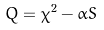Convert formula to latex. <formula><loc_0><loc_0><loc_500><loc_500>Q = \chi ^ { 2 } - \alpha S</formula> 